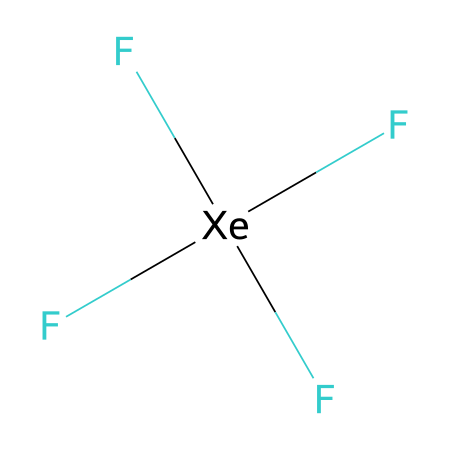What is the central atom in xenon tetrafluoride? The central atom is identified by its bonding position in the structure. In xenon tetrafluoride, xenon is located in the center of the molecule, bonded to four fluorine atoms.
Answer: xenon How many fluorine atoms are bonded to the xenon atom? By examining the structure, four fluorine atoms are clearly shown directly bonded to the central xenon atom, as indicated by the surrounding F symbols.
Answer: 4 What type of bonding is present in xenon tetrafluoride? The bonds between xenon and fluorine are covalent. This is determined based on the sharing of electron pairs between the atoms.
Answer: covalent What is the oxidation state of xenon in xenon tetrafluoride? The oxidation state is determined by considering the charge imparted by the surrounding electronegative fluorine atoms. Each fluorine has a charge of -1; thus, xenon has an oxidation state of +4.
Answer: +4 What type of compound is xenon tetrafluoride classified as? Xenon tetrafluoride is classified based on its bonding characteristics and the presence of more than four bonds around the central atom, making it a hypervalent compound.
Answer: hypervalent How many lone pairs does xenon have in xenon tetrafluoride? By analyzing the electron geometry and bond arrangement, it is evident that xenon in xenon tetrafluoride has zero lone pairs, as all valence electrons are involved in bonding.
Answer: 0 What molecular geometry does xenon tetrafluoride exhibit? The arrangement of the four bonded fluorine atoms around the xenon suggests a geometric structure based on the axial and equatorial positions leading to a square planar arrangement.
Answer: square planar 